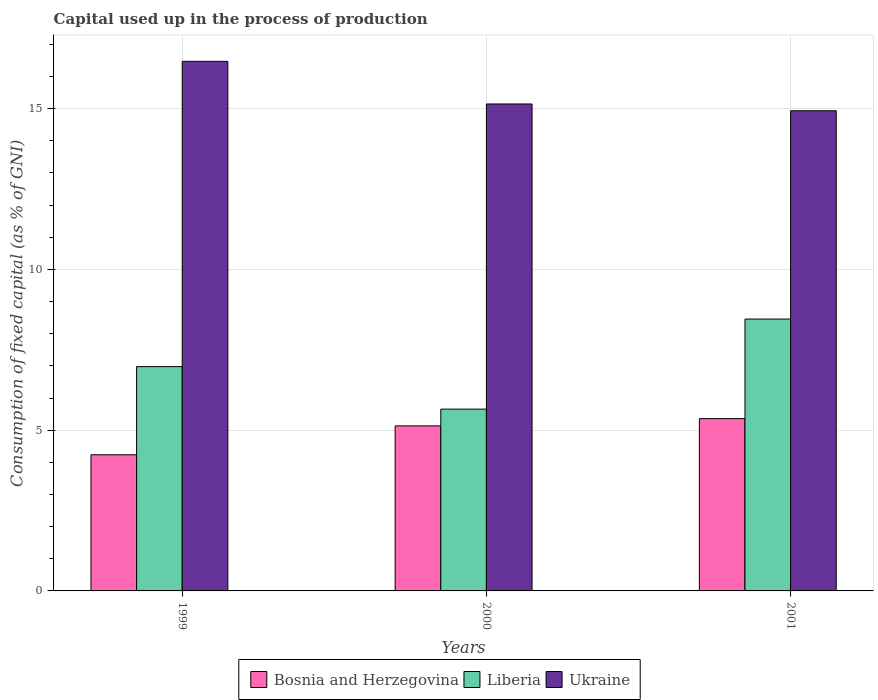Are the number of bars per tick equal to the number of legend labels?
Your response must be concise. Yes. How many bars are there on the 2nd tick from the left?
Offer a very short reply. 3. What is the capital used up in the process of production in Bosnia and Herzegovina in 1999?
Your answer should be compact. 4.23. Across all years, what is the maximum capital used up in the process of production in Bosnia and Herzegovina?
Provide a short and direct response. 5.36. Across all years, what is the minimum capital used up in the process of production in Liberia?
Keep it short and to the point. 5.65. In which year was the capital used up in the process of production in Ukraine maximum?
Make the answer very short. 1999. In which year was the capital used up in the process of production in Ukraine minimum?
Your response must be concise. 2001. What is the total capital used up in the process of production in Liberia in the graph?
Provide a succinct answer. 21.09. What is the difference between the capital used up in the process of production in Liberia in 1999 and that in 2001?
Offer a very short reply. -1.48. What is the difference between the capital used up in the process of production in Ukraine in 2001 and the capital used up in the process of production in Bosnia and Herzegovina in 1999?
Your answer should be compact. 10.7. What is the average capital used up in the process of production in Bosnia and Herzegovina per year?
Your answer should be compact. 4.91. In the year 2000, what is the difference between the capital used up in the process of production in Ukraine and capital used up in the process of production in Liberia?
Offer a terse response. 9.49. In how many years, is the capital used up in the process of production in Ukraine greater than 5 %?
Provide a succinct answer. 3. What is the ratio of the capital used up in the process of production in Bosnia and Herzegovina in 1999 to that in 2000?
Give a very brief answer. 0.83. What is the difference between the highest and the second highest capital used up in the process of production in Liberia?
Your answer should be compact. 1.48. What is the difference between the highest and the lowest capital used up in the process of production in Bosnia and Herzegovina?
Give a very brief answer. 1.12. In how many years, is the capital used up in the process of production in Ukraine greater than the average capital used up in the process of production in Ukraine taken over all years?
Offer a very short reply. 1. Is the sum of the capital used up in the process of production in Bosnia and Herzegovina in 1999 and 2001 greater than the maximum capital used up in the process of production in Ukraine across all years?
Keep it short and to the point. No. What does the 1st bar from the left in 2001 represents?
Provide a short and direct response. Bosnia and Herzegovina. What does the 3rd bar from the right in 2001 represents?
Make the answer very short. Bosnia and Herzegovina. Is it the case that in every year, the sum of the capital used up in the process of production in Liberia and capital used up in the process of production in Bosnia and Herzegovina is greater than the capital used up in the process of production in Ukraine?
Give a very brief answer. No. How many bars are there?
Provide a succinct answer. 9. How many years are there in the graph?
Provide a succinct answer. 3. How are the legend labels stacked?
Offer a terse response. Horizontal. What is the title of the graph?
Offer a terse response. Capital used up in the process of production. Does "High income: nonOECD" appear as one of the legend labels in the graph?
Ensure brevity in your answer.  No. What is the label or title of the Y-axis?
Provide a succinct answer. Consumption of fixed capital (as % of GNI). What is the Consumption of fixed capital (as % of GNI) of Bosnia and Herzegovina in 1999?
Your answer should be very brief. 4.23. What is the Consumption of fixed capital (as % of GNI) in Liberia in 1999?
Give a very brief answer. 6.98. What is the Consumption of fixed capital (as % of GNI) in Ukraine in 1999?
Your answer should be compact. 16.47. What is the Consumption of fixed capital (as % of GNI) in Bosnia and Herzegovina in 2000?
Provide a succinct answer. 5.13. What is the Consumption of fixed capital (as % of GNI) of Liberia in 2000?
Your answer should be compact. 5.65. What is the Consumption of fixed capital (as % of GNI) in Ukraine in 2000?
Give a very brief answer. 15.14. What is the Consumption of fixed capital (as % of GNI) in Bosnia and Herzegovina in 2001?
Offer a terse response. 5.36. What is the Consumption of fixed capital (as % of GNI) of Liberia in 2001?
Your answer should be very brief. 8.46. What is the Consumption of fixed capital (as % of GNI) in Ukraine in 2001?
Your response must be concise. 14.93. Across all years, what is the maximum Consumption of fixed capital (as % of GNI) of Bosnia and Herzegovina?
Your answer should be compact. 5.36. Across all years, what is the maximum Consumption of fixed capital (as % of GNI) of Liberia?
Provide a short and direct response. 8.46. Across all years, what is the maximum Consumption of fixed capital (as % of GNI) of Ukraine?
Your answer should be very brief. 16.47. Across all years, what is the minimum Consumption of fixed capital (as % of GNI) of Bosnia and Herzegovina?
Provide a short and direct response. 4.23. Across all years, what is the minimum Consumption of fixed capital (as % of GNI) of Liberia?
Ensure brevity in your answer.  5.65. Across all years, what is the minimum Consumption of fixed capital (as % of GNI) in Ukraine?
Make the answer very short. 14.93. What is the total Consumption of fixed capital (as % of GNI) of Bosnia and Herzegovina in the graph?
Your response must be concise. 14.73. What is the total Consumption of fixed capital (as % of GNI) in Liberia in the graph?
Give a very brief answer. 21.09. What is the total Consumption of fixed capital (as % of GNI) in Ukraine in the graph?
Provide a short and direct response. 46.55. What is the difference between the Consumption of fixed capital (as % of GNI) of Bosnia and Herzegovina in 1999 and that in 2000?
Keep it short and to the point. -0.9. What is the difference between the Consumption of fixed capital (as % of GNI) in Liberia in 1999 and that in 2000?
Your answer should be compact. 1.32. What is the difference between the Consumption of fixed capital (as % of GNI) in Ukraine in 1999 and that in 2000?
Your answer should be compact. 1.33. What is the difference between the Consumption of fixed capital (as % of GNI) in Bosnia and Herzegovina in 1999 and that in 2001?
Offer a terse response. -1.12. What is the difference between the Consumption of fixed capital (as % of GNI) of Liberia in 1999 and that in 2001?
Offer a terse response. -1.48. What is the difference between the Consumption of fixed capital (as % of GNI) in Ukraine in 1999 and that in 2001?
Ensure brevity in your answer.  1.54. What is the difference between the Consumption of fixed capital (as % of GNI) of Bosnia and Herzegovina in 2000 and that in 2001?
Your answer should be compact. -0.23. What is the difference between the Consumption of fixed capital (as % of GNI) of Liberia in 2000 and that in 2001?
Provide a short and direct response. -2.8. What is the difference between the Consumption of fixed capital (as % of GNI) in Ukraine in 2000 and that in 2001?
Your answer should be very brief. 0.21. What is the difference between the Consumption of fixed capital (as % of GNI) in Bosnia and Herzegovina in 1999 and the Consumption of fixed capital (as % of GNI) in Liberia in 2000?
Offer a very short reply. -1.42. What is the difference between the Consumption of fixed capital (as % of GNI) of Bosnia and Herzegovina in 1999 and the Consumption of fixed capital (as % of GNI) of Ukraine in 2000?
Provide a succinct answer. -10.91. What is the difference between the Consumption of fixed capital (as % of GNI) in Liberia in 1999 and the Consumption of fixed capital (as % of GNI) in Ukraine in 2000?
Your response must be concise. -8.17. What is the difference between the Consumption of fixed capital (as % of GNI) in Bosnia and Herzegovina in 1999 and the Consumption of fixed capital (as % of GNI) in Liberia in 2001?
Offer a terse response. -4.22. What is the difference between the Consumption of fixed capital (as % of GNI) of Bosnia and Herzegovina in 1999 and the Consumption of fixed capital (as % of GNI) of Ukraine in 2001?
Provide a succinct answer. -10.7. What is the difference between the Consumption of fixed capital (as % of GNI) of Liberia in 1999 and the Consumption of fixed capital (as % of GNI) of Ukraine in 2001?
Keep it short and to the point. -7.96. What is the difference between the Consumption of fixed capital (as % of GNI) of Bosnia and Herzegovina in 2000 and the Consumption of fixed capital (as % of GNI) of Liberia in 2001?
Your answer should be very brief. -3.32. What is the difference between the Consumption of fixed capital (as % of GNI) of Bosnia and Herzegovina in 2000 and the Consumption of fixed capital (as % of GNI) of Ukraine in 2001?
Keep it short and to the point. -9.8. What is the difference between the Consumption of fixed capital (as % of GNI) in Liberia in 2000 and the Consumption of fixed capital (as % of GNI) in Ukraine in 2001?
Offer a very short reply. -9.28. What is the average Consumption of fixed capital (as % of GNI) in Bosnia and Herzegovina per year?
Your answer should be compact. 4.91. What is the average Consumption of fixed capital (as % of GNI) of Liberia per year?
Provide a short and direct response. 7.03. What is the average Consumption of fixed capital (as % of GNI) in Ukraine per year?
Give a very brief answer. 15.52. In the year 1999, what is the difference between the Consumption of fixed capital (as % of GNI) of Bosnia and Herzegovina and Consumption of fixed capital (as % of GNI) of Liberia?
Offer a terse response. -2.74. In the year 1999, what is the difference between the Consumption of fixed capital (as % of GNI) in Bosnia and Herzegovina and Consumption of fixed capital (as % of GNI) in Ukraine?
Ensure brevity in your answer.  -12.24. In the year 1999, what is the difference between the Consumption of fixed capital (as % of GNI) of Liberia and Consumption of fixed capital (as % of GNI) of Ukraine?
Ensure brevity in your answer.  -9.49. In the year 2000, what is the difference between the Consumption of fixed capital (as % of GNI) of Bosnia and Herzegovina and Consumption of fixed capital (as % of GNI) of Liberia?
Your answer should be very brief. -0.52. In the year 2000, what is the difference between the Consumption of fixed capital (as % of GNI) in Bosnia and Herzegovina and Consumption of fixed capital (as % of GNI) in Ukraine?
Your answer should be very brief. -10.01. In the year 2000, what is the difference between the Consumption of fixed capital (as % of GNI) of Liberia and Consumption of fixed capital (as % of GNI) of Ukraine?
Give a very brief answer. -9.49. In the year 2001, what is the difference between the Consumption of fixed capital (as % of GNI) of Bosnia and Herzegovina and Consumption of fixed capital (as % of GNI) of Liberia?
Offer a very short reply. -3.1. In the year 2001, what is the difference between the Consumption of fixed capital (as % of GNI) in Bosnia and Herzegovina and Consumption of fixed capital (as % of GNI) in Ukraine?
Your answer should be very brief. -9.58. In the year 2001, what is the difference between the Consumption of fixed capital (as % of GNI) in Liberia and Consumption of fixed capital (as % of GNI) in Ukraine?
Offer a very short reply. -6.48. What is the ratio of the Consumption of fixed capital (as % of GNI) of Bosnia and Herzegovina in 1999 to that in 2000?
Your answer should be very brief. 0.82. What is the ratio of the Consumption of fixed capital (as % of GNI) in Liberia in 1999 to that in 2000?
Keep it short and to the point. 1.23. What is the ratio of the Consumption of fixed capital (as % of GNI) of Ukraine in 1999 to that in 2000?
Make the answer very short. 1.09. What is the ratio of the Consumption of fixed capital (as % of GNI) in Bosnia and Herzegovina in 1999 to that in 2001?
Your response must be concise. 0.79. What is the ratio of the Consumption of fixed capital (as % of GNI) of Liberia in 1999 to that in 2001?
Offer a very short reply. 0.82. What is the ratio of the Consumption of fixed capital (as % of GNI) in Ukraine in 1999 to that in 2001?
Your answer should be very brief. 1.1. What is the ratio of the Consumption of fixed capital (as % of GNI) in Bosnia and Herzegovina in 2000 to that in 2001?
Keep it short and to the point. 0.96. What is the ratio of the Consumption of fixed capital (as % of GNI) in Liberia in 2000 to that in 2001?
Your response must be concise. 0.67. What is the ratio of the Consumption of fixed capital (as % of GNI) in Ukraine in 2000 to that in 2001?
Make the answer very short. 1.01. What is the difference between the highest and the second highest Consumption of fixed capital (as % of GNI) of Bosnia and Herzegovina?
Provide a succinct answer. 0.23. What is the difference between the highest and the second highest Consumption of fixed capital (as % of GNI) in Liberia?
Offer a terse response. 1.48. What is the difference between the highest and the second highest Consumption of fixed capital (as % of GNI) of Ukraine?
Your answer should be very brief. 1.33. What is the difference between the highest and the lowest Consumption of fixed capital (as % of GNI) of Bosnia and Herzegovina?
Ensure brevity in your answer.  1.12. What is the difference between the highest and the lowest Consumption of fixed capital (as % of GNI) in Liberia?
Offer a very short reply. 2.8. What is the difference between the highest and the lowest Consumption of fixed capital (as % of GNI) in Ukraine?
Offer a terse response. 1.54. 